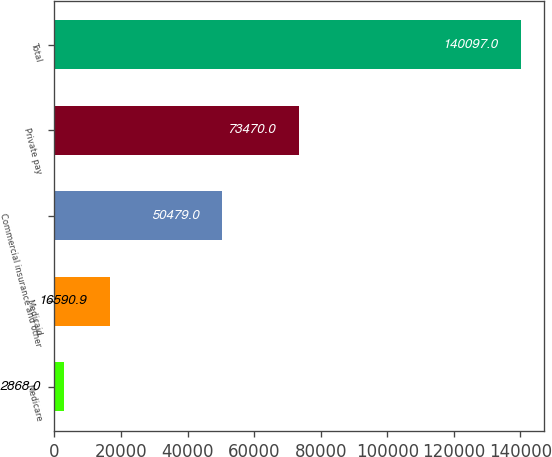<chart> <loc_0><loc_0><loc_500><loc_500><bar_chart><fcel>Medicare<fcel>Medicaid<fcel>Commercial insurance and other<fcel>Private pay<fcel>Total<nl><fcel>2868<fcel>16590.9<fcel>50479<fcel>73470<fcel>140097<nl></chart> 